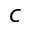Convert formula to latex. <formula><loc_0><loc_0><loc_500><loc_500>c</formula> 